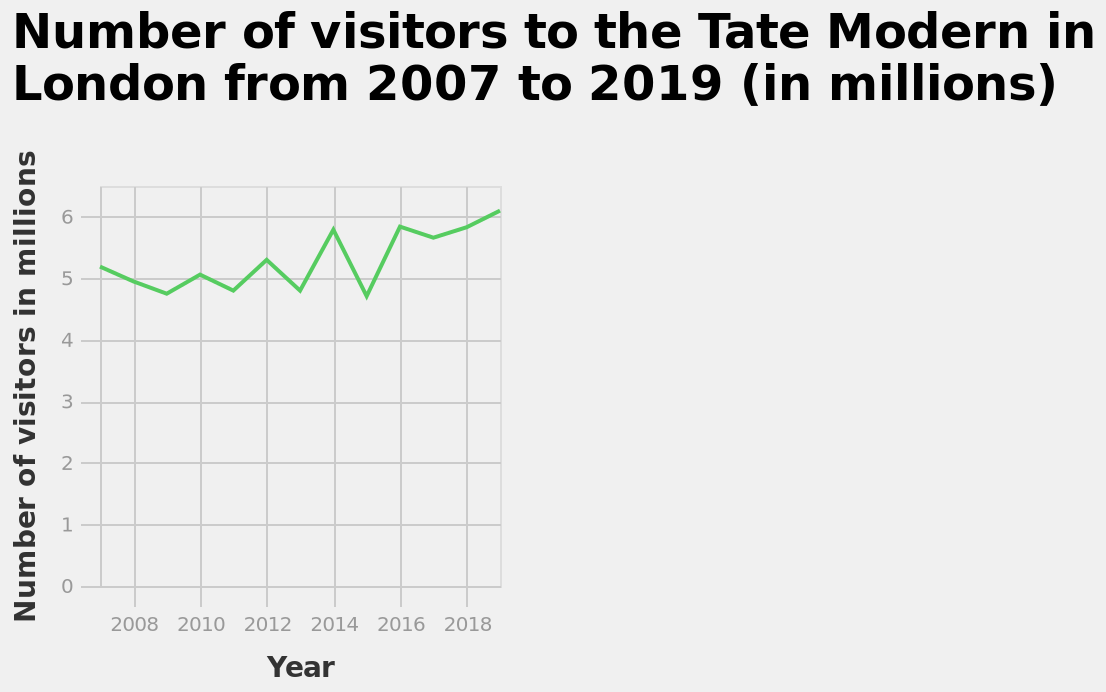<image>
What is the range of values on the y-axis? The range of values on the y-axis is from 0 to 6. What is the overall trend in the number of visitors to the gallery? The overall trend in the number of visitors to the gallery is a gradual progression. 